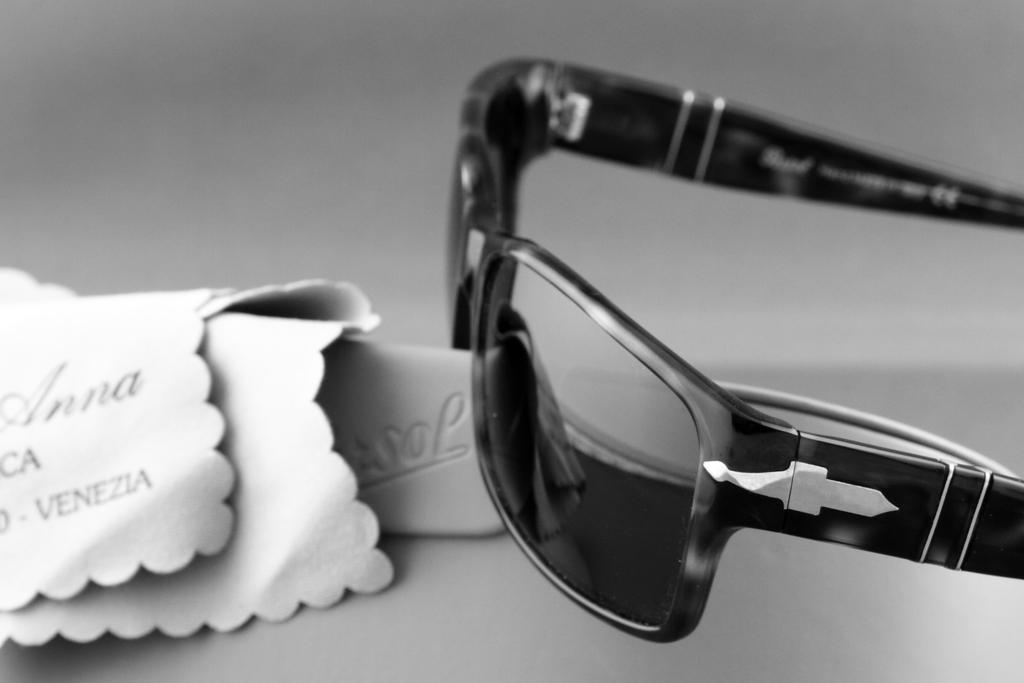What is the color scheme of the image? The image is black and white. What object can be seen on the right side of the image? There are goggles on the right side of the image. What can be found on the left side of the image? There are clothes and text on the left side of the image. What type of sound can be heard coming from the flag in the image? There is no flag present in the image, so it's not possible to determine what, if any, sound might be heard. 